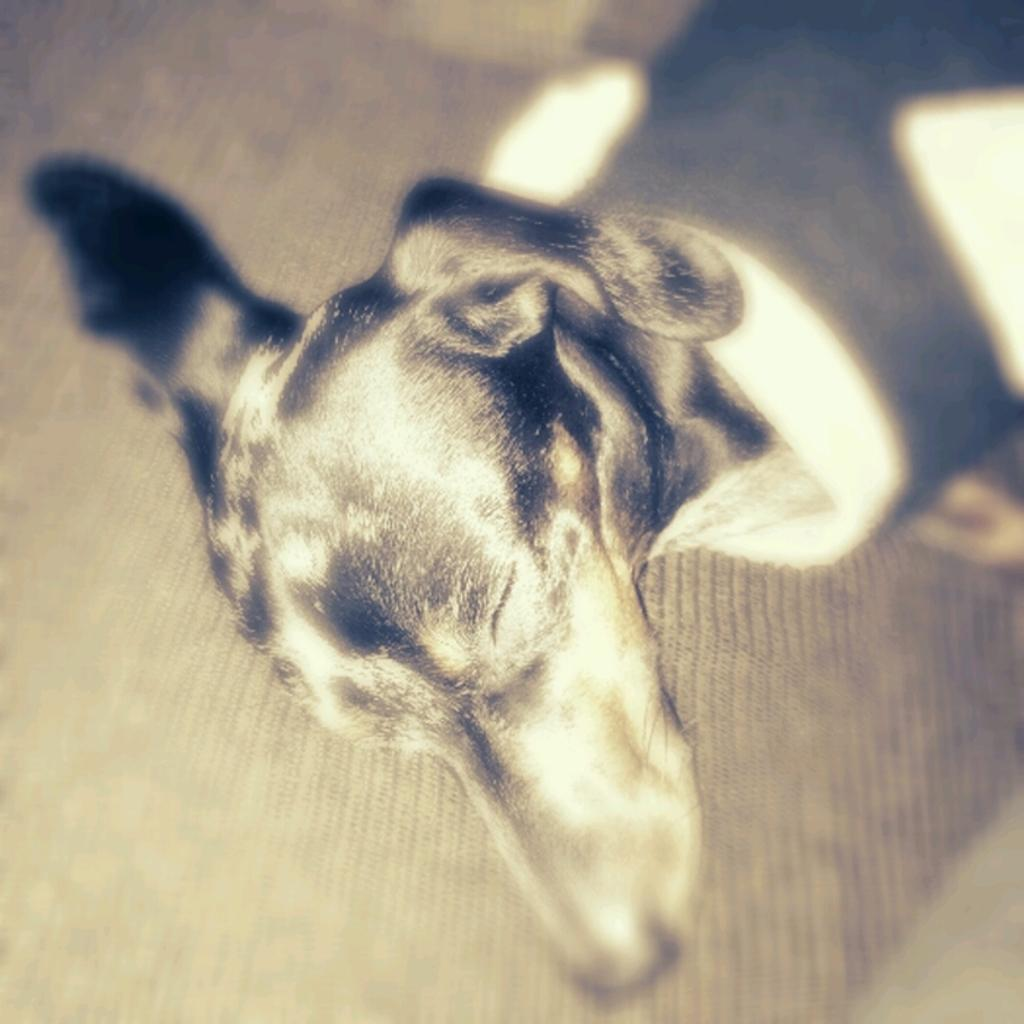What is the main subject in the foreground of the image? There is a dog in the foreground of the image. How close is the dog in the image? The dog is zoomed in. What can be seen in the background of the image? There is a floor carpet visible in the background of the image. Who won the competition that the dog participated in, as seen in the image? There is no competition present in the image, and therefore no winner can be identified. 